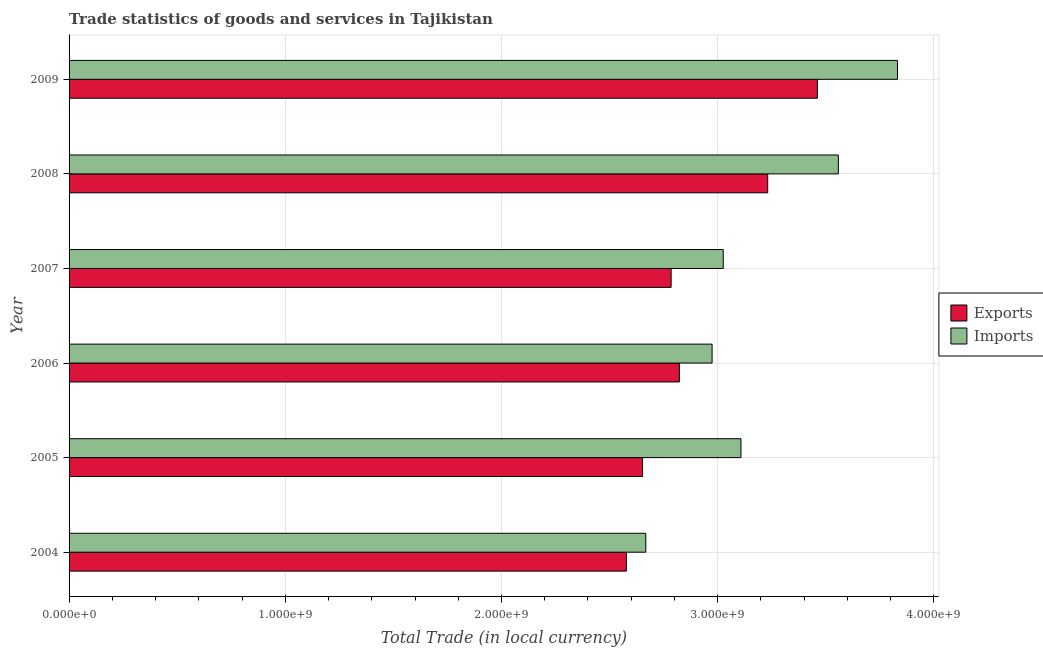How many groups of bars are there?
Offer a very short reply. 6. Are the number of bars on each tick of the Y-axis equal?
Make the answer very short. Yes. What is the label of the 2nd group of bars from the top?
Give a very brief answer. 2008. In how many cases, is the number of bars for a given year not equal to the number of legend labels?
Offer a terse response. 0. What is the imports of goods and services in 2008?
Give a very brief answer. 3.56e+09. Across all years, what is the maximum imports of goods and services?
Provide a succinct answer. 3.83e+09. Across all years, what is the minimum imports of goods and services?
Your response must be concise. 2.67e+09. In which year was the imports of goods and services maximum?
Make the answer very short. 2009. In which year was the export of goods and services minimum?
Your answer should be compact. 2004. What is the total imports of goods and services in the graph?
Give a very brief answer. 1.92e+1. What is the difference between the imports of goods and services in 2006 and that in 2007?
Give a very brief answer. -5.14e+07. What is the difference between the export of goods and services in 2008 and the imports of goods and services in 2005?
Ensure brevity in your answer.  1.24e+08. What is the average imports of goods and services per year?
Give a very brief answer. 3.19e+09. In the year 2004, what is the difference between the imports of goods and services and export of goods and services?
Your answer should be very brief. 8.98e+07. What is the ratio of the imports of goods and services in 2008 to that in 2009?
Make the answer very short. 0.93. What is the difference between the highest and the second highest imports of goods and services?
Your response must be concise. 2.73e+08. What is the difference between the highest and the lowest export of goods and services?
Your response must be concise. 8.83e+08. Is the sum of the export of goods and services in 2004 and 2009 greater than the maximum imports of goods and services across all years?
Offer a terse response. Yes. What does the 1st bar from the top in 2007 represents?
Provide a succinct answer. Imports. What does the 1st bar from the bottom in 2007 represents?
Your answer should be compact. Exports. What is the difference between two consecutive major ticks on the X-axis?
Make the answer very short. 1.00e+09. Does the graph contain any zero values?
Your answer should be very brief. No. Where does the legend appear in the graph?
Ensure brevity in your answer.  Center right. How many legend labels are there?
Provide a succinct answer. 2. What is the title of the graph?
Offer a terse response. Trade statistics of goods and services in Tajikistan. Does "Crop" appear as one of the legend labels in the graph?
Keep it short and to the point. No. What is the label or title of the X-axis?
Keep it short and to the point. Total Trade (in local currency). What is the Total Trade (in local currency) in Exports in 2004?
Provide a succinct answer. 2.58e+09. What is the Total Trade (in local currency) of Imports in 2004?
Your answer should be very brief. 2.67e+09. What is the Total Trade (in local currency) of Exports in 2005?
Your answer should be compact. 2.65e+09. What is the Total Trade (in local currency) in Imports in 2005?
Provide a short and direct response. 3.11e+09. What is the Total Trade (in local currency) of Exports in 2006?
Make the answer very short. 2.82e+09. What is the Total Trade (in local currency) in Imports in 2006?
Your answer should be compact. 2.97e+09. What is the Total Trade (in local currency) of Exports in 2007?
Keep it short and to the point. 2.78e+09. What is the Total Trade (in local currency) of Imports in 2007?
Your answer should be compact. 3.03e+09. What is the Total Trade (in local currency) of Exports in 2008?
Provide a short and direct response. 3.23e+09. What is the Total Trade (in local currency) of Imports in 2008?
Your response must be concise. 3.56e+09. What is the Total Trade (in local currency) of Exports in 2009?
Ensure brevity in your answer.  3.46e+09. What is the Total Trade (in local currency) in Imports in 2009?
Provide a short and direct response. 3.83e+09. Across all years, what is the maximum Total Trade (in local currency) of Exports?
Offer a very short reply. 3.46e+09. Across all years, what is the maximum Total Trade (in local currency) of Imports?
Your answer should be compact. 3.83e+09. Across all years, what is the minimum Total Trade (in local currency) in Exports?
Your answer should be compact. 2.58e+09. Across all years, what is the minimum Total Trade (in local currency) of Imports?
Make the answer very short. 2.67e+09. What is the total Total Trade (in local currency) of Exports in the graph?
Provide a succinct answer. 1.75e+1. What is the total Total Trade (in local currency) of Imports in the graph?
Offer a very short reply. 1.92e+1. What is the difference between the Total Trade (in local currency) in Exports in 2004 and that in 2005?
Ensure brevity in your answer.  -7.48e+07. What is the difference between the Total Trade (in local currency) in Imports in 2004 and that in 2005?
Offer a very short reply. -4.40e+08. What is the difference between the Total Trade (in local currency) of Exports in 2004 and that in 2006?
Keep it short and to the point. -2.45e+08. What is the difference between the Total Trade (in local currency) of Imports in 2004 and that in 2006?
Provide a succinct answer. -3.07e+08. What is the difference between the Total Trade (in local currency) in Exports in 2004 and that in 2007?
Give a very brief answer. -2.07e+08. What is the difference between the Total Trade (in local currency) of Imports in 2004 and that in 2007?
Your answer should be very brief. -3.58e+08. What is the difference between the Total Trade (in local currency) of Exports in 2004 and that in 2008?
Provide a short and direct response. -6.54e+08. What is the difference between the Total Trade (in local currency) in Imports in 2004 and that in 2008?
Your response must be concise. -8.91e+08. What is the difference between the Total Trade (in local currency) of Exports in 2004 and that in 2009?
Make the answer very short. -8.83e+08. What is the difference between the Total Trade (in local currency) of Imports in 2004 and that in 2009?
Keep it short and to the point. -1.16e+09. What is the difference between the Total Trade (in local currency) of Exports in 2005 and that in 2006?
Your answer should be compact. -1.70e+08. What is the difference between the Total Trade (in local currency) of Imports in 2005 and that in 2006?
Provide a succinct answer. 1.33e+08. What is the difference between the Total Trade (in local currency) of Exports in 2005 and that in 2007?
Keep it short and to the point. -1.32e+08. What is the difference between the Total Trade (in local currency) in Imports in 2005 and that in 2007?
Provide a short and direct response. 8.21e+07. What is the difference between the Total Trade (in local currency) of Exports in 2005 and that in 2008?
Offer a very short reply. -5.79e+08. What is the difference between the Total Trade (in local currency) in Imports in 2005 and that in 2008?
Your answer should be very brief. -4.50e+08. What is the difference between the Total Trade (in local currency) in Exports in 2005 and that in 2009?
Offer a terse response. -8.09e+08. What is the difference between the Total Trade (in local currency) in Imports in 2005 and that in 2009?
Offer a terse response. -7.24e+08. What is the difference between the Total Trade (in local currency) in Exports in 2006 and that in 2007?
Provide a succinct answer. 3.81e+07. What is the difference between the Total Trade (in local currency) of Imports in 2006 and that in 2007?
Your response must be concise. -5.14e+07. What is the difference between the Total Trade (in local currency) in Exports in 2006 and that in 2008?
Your answer should be compact. -4.09e+08. What is the difference between the Total Trade (in local currency) of Imports in 2006 and that in 2008?
Provide a succinct answer. -5.84e+08. What is the difference between the Total Trade (in local currency) of Exports in 2006 and that in 2009?
Keep it short and to the point. -6.38e+08. What is the difference between the Total Trade (in local currency) of Imports in 2006 and that in 2009?
Your response must be concise. -8.57e+08. What is the difference between the Total Trade (in local currency) of Exports in 2007 and that in 2008?
Your answer should be very brief. -4.47e+08. What is the difference between the Total Trade (in local currency) of Imports in 2007 and that in 2008?
Provide a succinct answer. -5.33e+08. What is the difference between the Total Trade (in local currency) of Exports in 2007 and that in 2009?
Provide a short and direct response. -6.76e+08. What is the difference between the Total Trade (in local currency) of Imports in 2007 and that in 2009?
Give a very brief answer. -8.06e+08. What is the difference between the Total Trade (in local currency) in Exports in 2008 and that in 2009?
Provide a succinct answer. -2.30e+08. What is the difference between the Total Trade (in local currency) of Imports in 2008 and that in 2009?
Make the answer very short. -2.73e+08. What is the difference between the Total Trade (in local currency) of Exports in 2004 and the Total Trade (in local currency) of Imports in 2005?
Give a very brief answer. -5.30e+08. What is the difference between the Total Trade (in local currency) in Exports in 2004 and the Total Trade (in local currency) in Imports in 2006?
Provide a succinct answer. -3.96e+08. What is the difference between the Total Trade (in local currency) in Exports in 2004 and the Total Trade (in local currency) in Imports in 2007?
Provide a short and direct response. -4.48e+08. What is the difference between the Total Trade (in local currency) in Exports in 2004 and the Total Trade (in local currency) in Imports in 2008?
Provide a succinct answer. -9.80e+08. What is the difference between the Total Trade (in local currency) in Exports in 2004 and the Total Trade (in local currency) in Imports in 2009?
Provide a succinct answer. -1.25e+09. What is the difference between the Total Trade (in local currency) of Exports in 2005 and the Total Trade (in local currency) of Imports in 2006?
Your answer should be compact. -3.22e+08. What is the difference between the Total Trade (in local currency) in Exports in 2005 and the Total Trade (in local currency) in Imports in 2007?
Your answer should be very brief. -3.73e+08. What is the difference between the Total Trade (in local currency) in Exports in 2005 and the Total Trade (in local currency) in Imports in 2008?
Offer a terse response. -9.06e+08. What is the difference between the Total Trade (in local currency) of Exports in 2005 and the Total Trade (in local currency) of Imports in 2009?
Provide a succinct answer. -1.18e+09. What is the difference between the Total Trade (in local currency) in Exports in 2006 and the Total Trade (in local currency) in Imports in 2007?
Offer a very short reply. -2.03e+08. What is the difference between the Total Trade (in local currency) of Exports in 2006 and the Total Trade (in local currency) of Imports in 2008?
Offer a very short reply. -7.35e+08. What is the difference between the Total Trade (in local currency) in Exports in 2006 and the Total Trade (in local currency) in Imports in 2009?
Ensure brevity in your answer.  -1.01e+09. What is the difference between the Total Trade (in local currency) in Exports in 2007 and the Total Trade (in local currency) in Imports in 2008?
Provide a short and direct response. -7.73e+08. What is the difference between the Total Trade (in local currency) in Exports in 2007 and the Total Trade (in local currency) in Imports in 2009?
Offer a very short reply. -1.05e+09. What is the difference between the Total Trade (in local currency) of Exports in 2008 and the Total Trade (in local currency) of Imports in 2009?
Ensure brevity in your answer.  -6.00e+08. What is the average Total Trade (in local currency) of Exports per year?
Give a very brief answer. 2.92e+09. What is the average Total Trade (in local currency) in Imports per year?
Your answer should be very brief. 3.19e+09. In the year 2004, what is the difference between the Total Trade (in local currency) of Exports and Total Trade (in local currency) of Imports?
Your response must be concise. -8.98e+07. In the year 2005, what is the difference between the Total Trade (in local currency) of Exports and Total Trade (in local currency) of Imports?
Give a very brief answer. -4.55e+08. In the year 2006, what is the difference between the Total Trade (in local currency) of Exports and Total Trade (in local currency) of Imports?
Ensure brevity in your answer.  -1.51e+08. In the year 2007, what is the difference between the Total Trade (in local currency) in Exports and Total Trade (in local currency) in Imports?
Your answer should be very brief. -2.41e+08. In the year 2008, what is the difference between the Total Trade (in local currency) of Exports and Total Trade (in local currency) of Imports?
Your answer should be compact. -3.27e+08. In the year 2009, what is the difference between the Total Trade (in local currency) in Exports and Total Trade (in local currency) in Imports?
Keep it short and to the point. -3.70e+08. What is the ratio of the Total Trade (in local currency) of Exports in 2004 to that in 2005?
Your answer should be very brief. 0.97. What is the ratio of the Total Trade (in local currency) of Imports in 2004 to that in 2005?
Provide a succinct answer. 0.86. What is the ratio of the Total Trade (in local currency) of Exports in 2004 to that in 2006?
Offer a terse response. 0.91. What is the ratio of the Total Trade (in local currency) in Imports in 2004 to that in 2006?
Ensure brevity in your answer.  0.9. What is the ratio of the Total Trade (in local currency) of Exports in 2004 to that in 2007?
Provide a short and direct response. 0.93. What is the ratio of the Total Trade (in local currency) of Imports in 2004 to that in 2007?
Give a very brief answer. 0.88. What is the ratio of the Total Trade (in local currency) of Exports in 2004 to that in 2008?
Offer a very short reply. 0.8. What is the ratio of the Total Trade (in local currency) in Imports in 2004 to that in 2008?
Provide a succinct answer. 0.75. What is the ratio of the Total Trade (in local currency) of Exports in 2004 to that in 2009?
Make the answer very short. 0.74. What is the ratio of the Total Trade (in local currency) in Imports in 2004 to that in 2009?
Keep it short and to the point. 0.7. What is the ratio of the Total Trade (in local currency) in Exports in 2005 to that in 2006?
Provide a short and direct response. 0.94. What is the ratio of the Total Trade (in local currency) of Imports in 2005 to that in 2006?
Your answer should be very brief. 1.04. What is the ratio of the Total Trade (in local currency) of Exports in 2005 to that in 2007?
Give a very brief answer. 0.95. What is the ratio of the Total Trade (in local currency) of Imports in 2005 to that in 2007?
Keep it short and to the point. 1.03. What is the ratio of the Total Trade (in local currency) of Exports in 2005 to that in 2008?
Your answer should be very brief. 0.82. What is the ratio of the Total Trade (in local currency) of Imports in 2005 to that in 2008?
Provide a succinct answer. 0.87. What is the ratio of the Total Trade (in local currency) in Exports in 2005 to that in 2009?
Provide a short and direct response. 0.77. What is the ratio of the Total Trade (in local currency) in Imports in 2005 to that in 2009?
Your response must be concise. 0.81. What is the ratio of the Total Trade (in local currency) of Exports in 2006 to that in 2007?
Provide a succinct answer. 1.01. What is the ratio of the Total Trade (in local currency) in Exports in 2006 to that in 2008?
Give a very brief answer. 0.87. What is the ratio of the Total Trade (in local currency) in Imports in 2006 to that in 2008?
Your answer should be compact. 0.84. What is the ratio of the Total Trade (in local currency) of Exports in 2006 to that in 2009?
Provide a short and direct response. 0.82. What is the ratio of the Total Trade (in local currency) of Imports in 2006 to that in 2009?
Provide a succinct answer. 0.78. What is the ratio of the Total Trade (in local currency) of Exports in 2007 to that in 2008?
Provide a succinct answer. 0.86. What is the ratio of the Total Trade (in local currency) of Imports in 2007 to that in 2008?
Your answer should be compact. 0.85. What is the ratio of the Total Trade (in local currency) in Exports in 2007 to that in 2009?
Give a very brief answer. 0.8. What is the ratio of the Total Trade (in local currency) of Imports in 2007 to that in 2009?
Offer a very short reply. 0.79. What is the ratio of the Total Trade (in local currency) in Exports in 2008 to that in 2009?
Offer a very short reply. 0.93. What is the difference between the highest and the second highest Total Trade (in local currency) in Exports?
Your answer should be very brief. 2.30e+08. What is the difference between the highest and the second highest Total Trade (in local currency) in Imports?
Ensure brevity in your answer.  2.73e+08. What is the difference between the highest and the lowest Total Trade (in local currency) in Exports?
Provide a succinct answer. 8.83e+08. What is the difference between the highest and the lowest Total Trade (in local currency) of Imports?
Keep it short and to the point. 1.16e+09. 